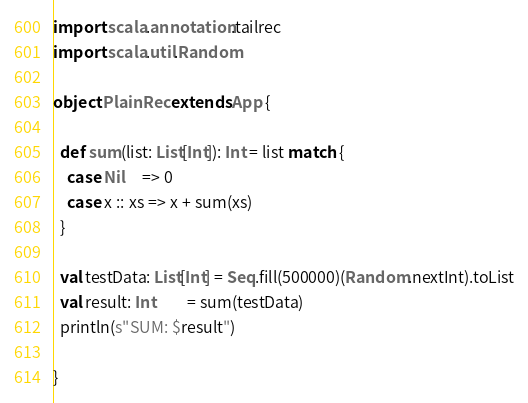Convert code to text. <code><loc_0><loc_0><loc_500><loc_500><_Scala_>import scala.annotation.tailrec
import scala.util.Random

object PlainRec extends App {

  def sum(list: List[Int]): Int = list match {
    case Nil     => 0
    case x :: xs => x + sum(xs)
  }

  val testData: List[Int] = Seq.fill(500000)(Random.nextInt).toList
  val result: Int         = sum(testData)
  println(s"SUM: $result")

}
</code> 